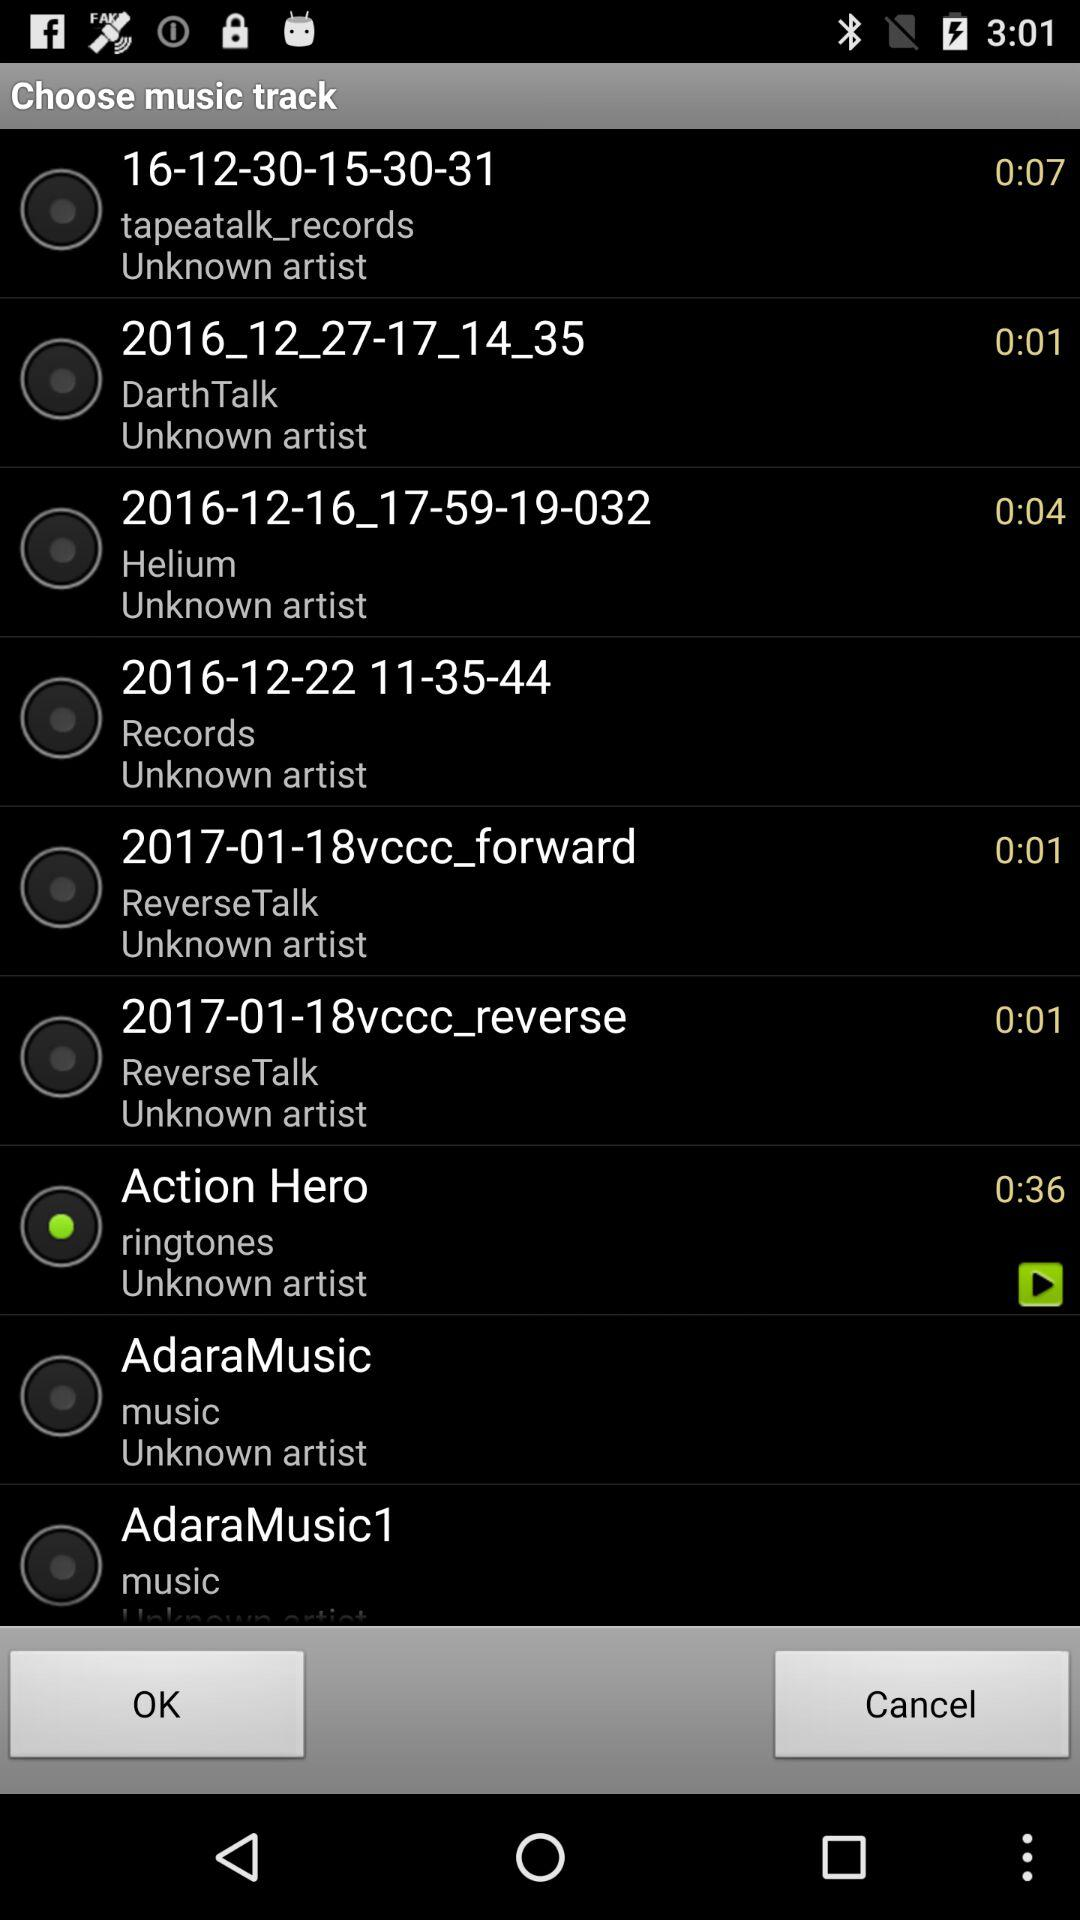How long does the "2017-01-18vccc_reverse" ringtone last? It lasts for 1 second. 